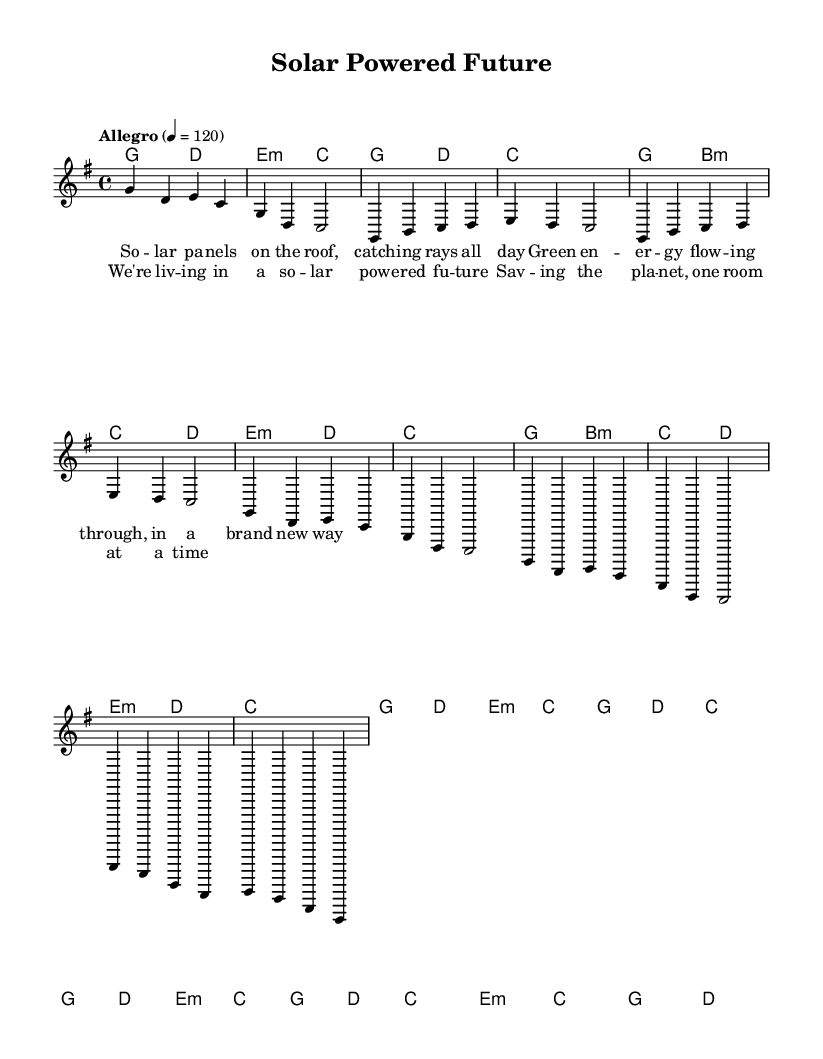What is the key signature of this music? The key signature is indicated by the sharp sign on the staff, which shows that the key is G major, as it has one sharp.
Answer: G major What is the time signature of this music? The time signature is located at the beginning of the staff, showing that it is 4/4, meaning there are four beats in each measure.
Answer: 4/4 What tempo is indicated for this piece? The tempo marking "Allegro" suggests a lively and fast pace, with a specific speed of 120 beats per minute shown numerically.
Answer: 120 How many measures are in the verse? The verse section consists of eight measures in total when counted, following the format of each line representing a measure.
Answer: Eight What are the first two chords played in the piece? The first two chords listed at the beginning are G major and D major, which are typically the main harmonic support for the melody introduced.
Answer: G, D How many times does the chorus repeat? By analyzing the structure presented in the sheet music, the chorus is repeated twice following the verse, emphasizing its importance.
Answer: Twice What lyrical theme does the song celebrate? The lyrics express a theme centered around solar energy and environmental sustainability, celebrating eco-friendly initiatives and green living.
Answer: Eco-friendly initiatives 